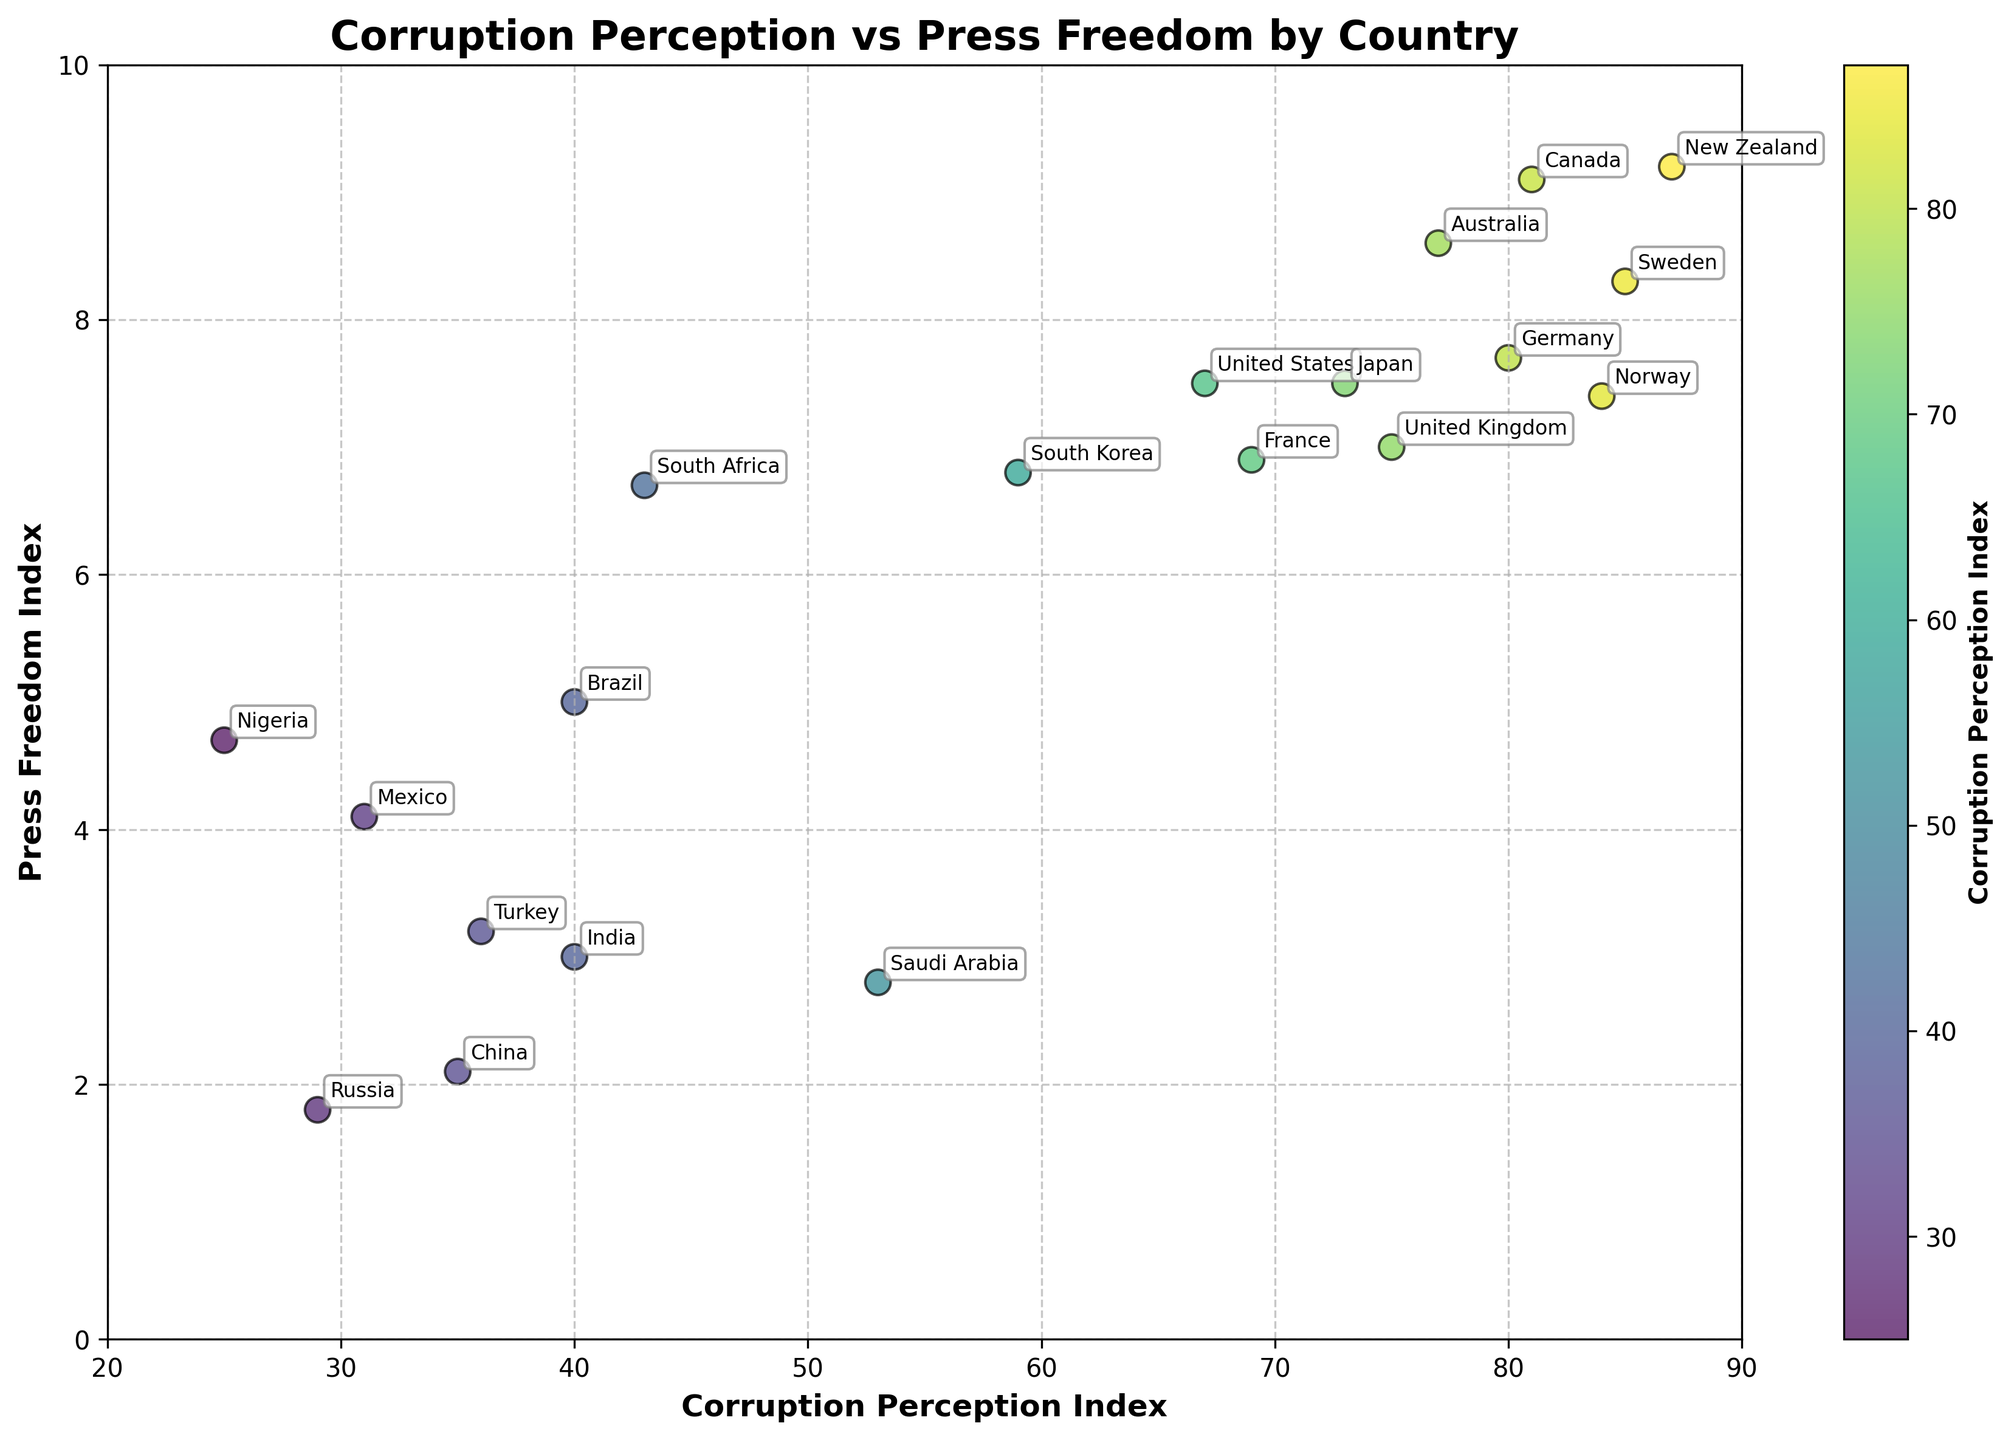Which country has the highest Corruption Perception Index? The highest point along the x-axis (Corruption Perception Index) represents the country with the highest score. New Zealand has the highest score, 87.
Answer: New Zealand How many countries have a Press Freedom Index above 7? Count the number of data points that are positioned above the value of 7 on the y-axis (Press Freedom Index).
Answer: 7 What is the Press Freedom Index of Nigeria? Locate Nigeria on the scatter plot and check its position on the y-axis. Nigeria is positioned at a Press Freedom Index of 4.7.
Answer: 4.7 Compare the Corruption Perception Index of Brazil and India. Which one is higher? Find the points for Brazil and India on the x-axis (Corruption Perception Index). Both Brazil and India have the same score of 40.
Answer: Equal Which countries have both a Corruption Perception Index above 80 and a Press Freedom Index above 8? Locate the countries that are positioned above 80 on the x-axis and above 8 on the y-axis. Norway, Sweden, Canada, and New Zealand meet this criteria.
Answer: Norway, Sweden, Canada, New Zealand What is the average Corruption Perception Index of the countries with a Press Freedom Index below 5? Identify the countries below Press Freedom Index of 5 (India, Russia, China, Nigeria, Mexico, Turkey, Saudi Arabia). Calculate their average Corruption Perception Index: (40+29+35+25+31+36+53)/7 = 35.57.
Answer: 35.57 Is there a country with a higher Press Freedom Index than Germany but a lower Corruption Perception Index? First identify Germany's indices (CPI: 80, PFI: 7.7). Then look for countries with PFI > 7.7 and CPI < 80. Canada and New Zealand meet this criteria.
Answer: Canada, New Zealand Which country has the lowest Corruption Perception Index, and what is its Press Freedom Index value? Find the lowest point on the x-axis (Corruption Perception Index), which is Nigeria with a score of 25 and a Press Freedom Index of 4.7.
Answer: Nigeria, 4.7 Compare the Corruption Perception Index of the United States and Japan. Which country has a higher index? Locate the United States (67) and Japan (73) on the x-axis. Japan has a higher Corruption Perception Index.
Answer: Japan How does the Press Freedom Index of China compare to that of Russia? Locate China (2.1) and Russia (1.8) on the y-axis. China has a slightly higher Press Freedom Index than Russia.
Answer: China 